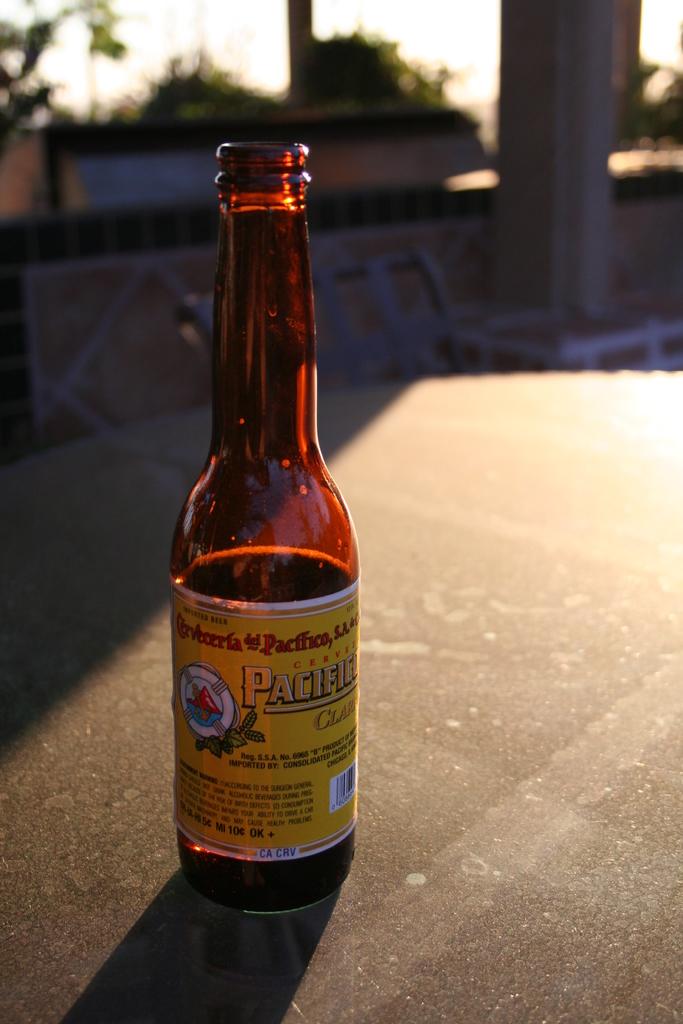What is the brand name of this alcohol?
Make the answer very short. Pacific. 